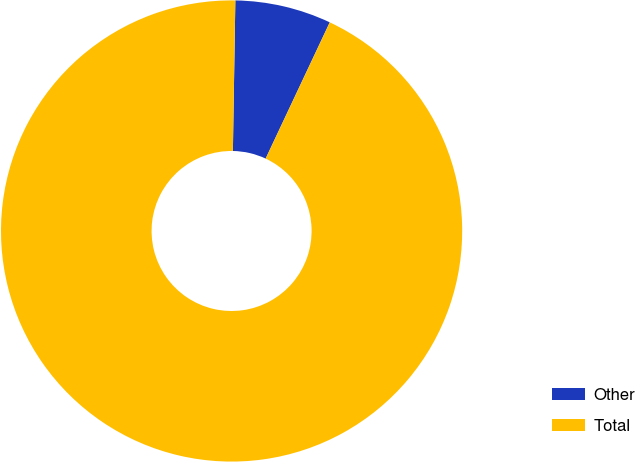Convert chart. <chart><loc_0><loc_0><loc_500><loc_500><pie_chart><fcel>Other<fcel>Total<nl><fcel>6.74%<fcel>93.26%<nl></chart> 